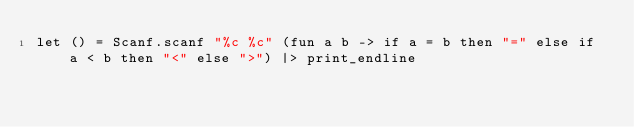<code> <loc_0><loc_0><loc_500><loc_500><_OCaml_>let () = Scanf.scanf "%c %c" (fun a b -> if a = b then "=" else if a < b then "<" else ">") |> print_endline
</code> 